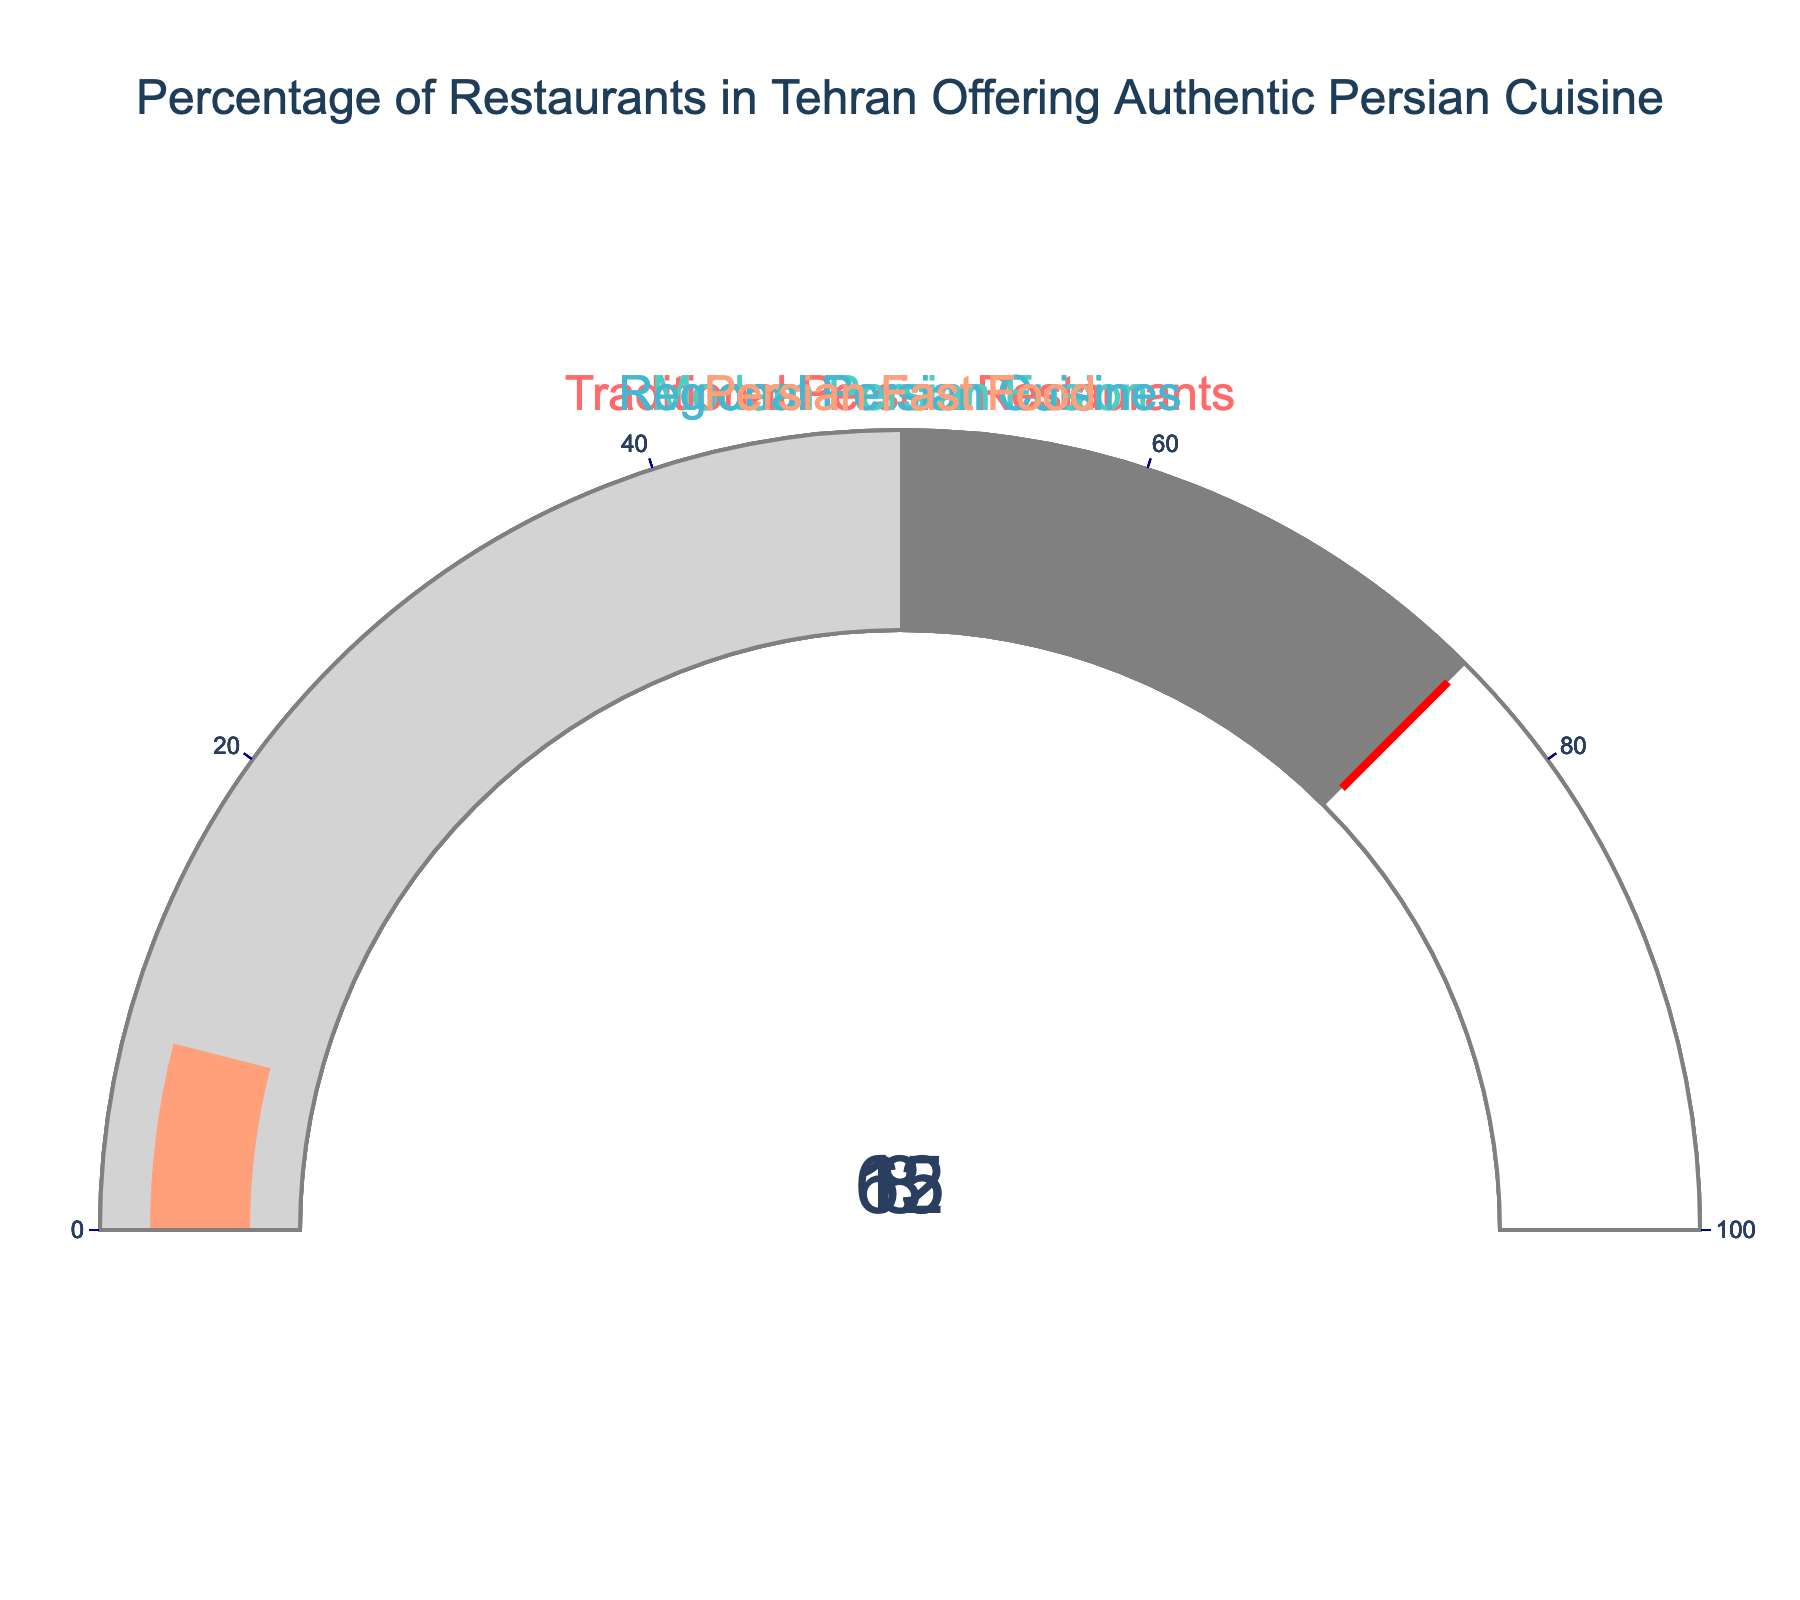What percentage of restaurants in Tehran offer traditional Persian cuisine? The gauge chart for "Traditional Persian Restaurants" shows a reading of 65%.
Answer: 65% Which type of restaurant has the smallest percentage of offerings? The gauge chart for "Persian Fast Food" shows a reading of 8%, which is the smallest among the categories.
Answer: Persian Fast Food What's the combined percentage of restaurants offering traditional Persian and modern Persian fusion cuisines? Traditional Persian Restaurants have 65% and Modern Persian Fusion has 15%. Adding these together gives 65 + 15 = 80.
Answer: 80% How much higher is the percentage of traditional Persian restaurants compared to Persian fast food restaurants? Traditional Persian Restaurants have 65% and Persian Fast Food has 8%. The difference is 65 - 8 = 57.
Answer: 57% What's the total percentage of restaurants offering regional Persian cuisines and Persian fast food combined? Regional Persian Cuisines have 12% and Persian Fast Food has 8%. Adding these together gives 12 + 8 = 20.
Answer: 20% Which type of restaurant has a percentage closest to 10%? The gauge chart for "Regional Persian Cuisines" shows a reading of 12%, which is closest to 10% among all categories.
Answer: Regional Persian Cuisines How much more common are modern Persian fusion restaurants than Persian fast food restaurants? Modern Persian Fusion has 15% and Persian Fast Food has 8%. The difference is 15 - 8 = 7.
Answer: 7 What is the difference in percentage between traditional Persian restaurants and regional Persian cuisines? Traditional Persian Restaurants have 65% and Regional Persian Cuisines have 12%. The difference is 65 - 12 = 53.
Answer: 53 Of the given restaurant types, which accounts for over half of the total percentage? The gauge chart for "Traditional Persian Restaurants" shows a reading of 65%, which is more than half of the total 100%.
Answer: Traditional Persian Restaurants 